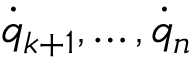<formula> <loc_0><loc_0><loc_500><loc_500>{ \dot { q } } _ { k + 1 } , \dots , { \dot { q } } _ { n }</formula> 